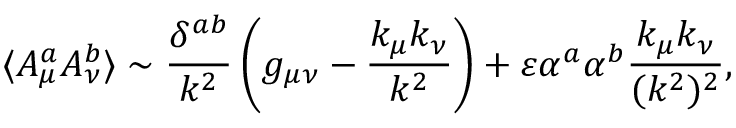Convert formula to latex. <formula><loc_0><loc_0><loc_500><loc_500>\langle A _ { \mu } ^ { a } A _ { \nu } ^ { b } \rangle \sim { \frac { \delta ^ { a b } } { k ^ { 2 } } } \left ( g _ { \mu \nu } - { \frac { k _ { \mu } k _ { \nu } } { k ^ { 2 } } } \right ) + \varepsilon \alpha ^ { a } \alpha ^ { b } { \frac { k _ { \mu } k _ { \nu } } { ( k ^ { 2 } ) ^ { 2 } } } ,</formula> 